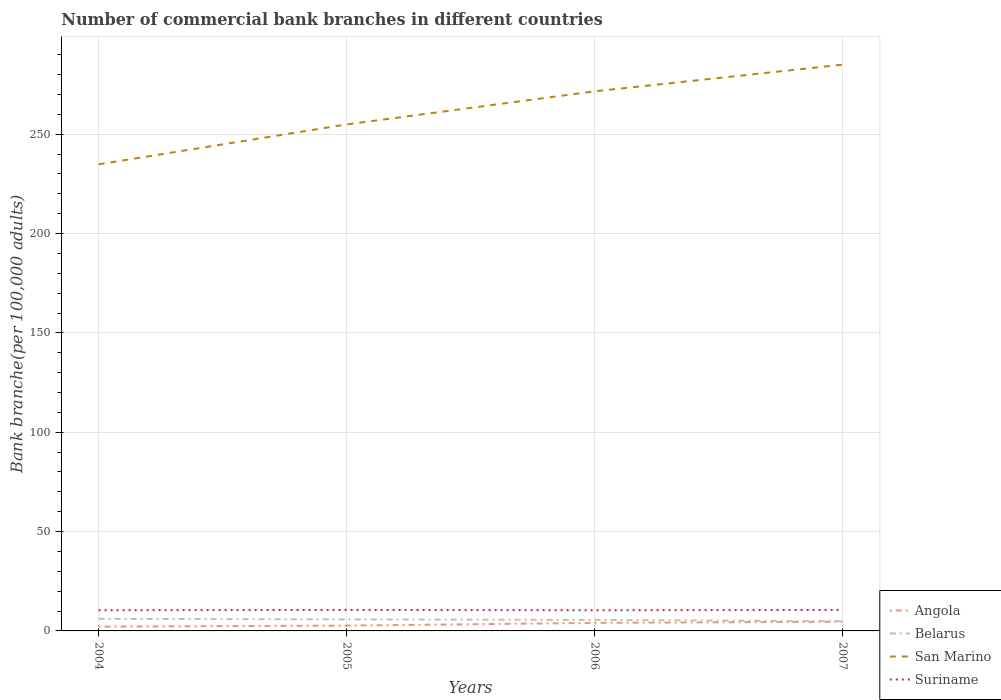How many different coloured lines are there?
Your answer should be very brief. 4. Does the line corresponding to Belarus intersect with the line corresponding to Angola?
Give a very brief answer. No. Is the number of lines equal to the number of legend labels?
Your response must be concise. Yes. Across all years, what is the maximum number of commercial bank branches in Belarus?
Your answer should be very brief. 4.87. In which year was the number of commercial bank branches in San Marino maximum?
Make the answer very short. 2004. What is the total number of commercial bank branches in Suriname in the graph?
Your answer should be compact. -0.13. What is the difference between the highest and the second highest number of commercial bank branches in Angola?
Your response must be concise. 2.49. Is the number of commercial bank branches in San Marino strictly greater than the number of commercial bank branches in Belarus over the years?
Your answer should be very brief. No. How many lines are there?
Provide a short and direct response. 4. Does the graph contain grids?
Provide a short and direct response. Yes. How many legend labels are there?
Keep it short and to the point. 4. How are the legend labels stacked?
Keep it short and to the point. Vertical. What is the title of the graph?
Offer a terse response. Number of commercial bank branches in different countries. What is the label or title of the Y-axis?
Your response must be concise. Bank branche(per 100,0 adults). What is the Bank branche(per 100,000 adults) in Angola in 2004?
Your answer should be compact. 2.16. What is the Bank branche(per 100,000 adults) in Belarus in 2004?
Provide a succinct answer. 6.09. What is the Bank branche(per 100,000 adults) in San Marino in 2004?
Ensure brevity in your answer.  234.84. What is the Bank branche(per 100,000 adults) of Suriname in 2004?
Your response must be concise. 10.43. What is the Bank branche(per 100,000 adults) of Angola in 2005?
Give a very brief answer. 2.67. What is the Bank branche(per 100,000 adults) in Belarus in 2005?
Keep it short and to the point. 5.8. What is the Bank branche(per 100,000 adults) of San Marino in 2005?
Your response must be concise. 254.92. What is the Bank branche(per 100,000 adults) of Suriname in 2005?
Keep it short and to the point. 10.56. What is the Bank branche(per 100,000 adults) in Angola in 2006?
Offer a very short reply. 4.04. What is the Bank branche(per 100,000 adults) in Belarus in 2006?
Keep it short and to the point. 5.56. What is the Bank branche(per 100,000 adults) in San Marino in 2006?
Give a very brief answer. 271.59. What is the Bank branche(per 100,000 adults) of Suriname in 2006?
Provide a short and direct response. 10.42. What is the Bank branche(per 100,000 adults) of Angola in 2007?
Keep it short and to the point. 4.64. What is the Bank branche(per 100,000 adults) in Belarus in 2007?
Keep it short and to the point. 4.87. What is the Bank branche(per 100,000 adults) in San Marino in 2007?
Offer a terse response. 285. What is the Bank branche(per 100,000 adults) of Suriname in 2007?
Your answer should be compact. 10.56. Across all years, what is the maximum Bank branche(per 100,000 adults) in Angola?
Offer a terse response. 4.64. Across all years, what is the maximum Bank branche(per 100,000 adults) in Belarus?
Ensure brevity in your answer.  6.09. Across all years, what is the maximum Bank branche(per 100,000 adults) in San Marino?
Make the answer very short. 285. Across all years, what is the maximum Bank branche(per 100,000 adults) in Suriname?
Keep it short and to the point. 10.56. Across all years, what is the minimum Bank branche(per 100,000 adults) in Angola?
Your answer should be compact. 2.16. Across all years, what is the minimum Bank branche(per 100,000 adults) in Belarus?
Your answer should be very brief. 4.87. Across all years, what is the minimum Bank branche(per 100,000 adults) of San Marino?
Offer a terse response. 234.84. Across all years, what is the minimum Bank branche(per 100,000 adults) in Suriname?
Make the answer very short. 10.42. What is the total Bank branche(per 100,000 adults) in Angola in the graph?
Offer a very short reply. 13.51. What is the total Bank branche(per 100,000 adults) in Belarus in the graph?
Your response must be concise. 22.32. What is the total Bank branche(per 100,000 adults) of San Marino in the graph?
Provide a short and direct response. 1046.35. What is the total Bank branche(per 100,000 adults) in Suriname in the graph?
Ensure brevity in your answer.  41.97. What is the difference between the Bank branche(per 100,000 adults) in Angola in 2004 and that in 2005?
Make the answer very short. -0.52. What is the difference between the Bank branche(per 100,000 adults) of Belarus in 2004 and that in 2005?
Offer a very short reply. 0.3. What is the difference between the Bank branche(per 100,000 adults) of San Marino in 2004 and that in 2005?
Offer a very short reply. -20.07. What is the difference between the Bank branche(per 100,000 adults) in Suriname in 2004 and that in 2005?
Your response must be concise. -0.14. What is the difference between the Bank branche(per 100,000 adults) in Angola in 2004 and that in 2006?
Your answer should be compact. -1.88. What is the difference between the Bank branche(per 100,000 adults) in Belarus in 2004 and that in 2006?
Offer a terse response. 0.53. What is the difference between the Bank branche(per 100,000 adults) of San Marino in 2004 and that in 2006?
Your answer should be very brief. -36.75. What is the difference between the Bank branche(per 100,000 adults) in Suriname in 2004 and that in 2006?
Your response must be concise. 0.01. What is the difference between the Bank branche(per 100,000 adults) of Angola in 2004 and that in 2007?
Provide a succinct answer. -2.49. What is the difference between the Bank branche(per 100,000 adults) in Belarus in 2004 and that in 2007?
Your answer should be compact. 1.22. What is the difference between the Bank branche(per 100,000 adults) of San Marino in 2004 and that in 2007?
Your answer should be very brief. -50.16. What is the difference between the Bank branche(per 100,000 adults) of Suriname in 2004 and that in 2007?
Provide a succinct answer. -0.13. What is the difference between the Bank branche(per 100,000 adults) in Angola in 2005 and that in 2006?
Offer a terse response. -1.37. What is the difference between the Bank branche(per 100,000 adults) of Belarus in 2005 and that in 2006?
Keep it short and to the point. 0.23. What is the difference between the Bank branche(per 100,000 adults) of San Marino in 2005 and that in 2006?
Make the answer very short. -16.68. What is the difference between the Bank branche(per 100,000 adults) of Suriname in 2005 and that in 2006?
Offer a terse response. 0.14. What is the difference between the Bank branche(per 100,000 adults) in Angola in 2005 and that in 2007?
Your response must be concise. -1.97. What is the difference between the Bank branche(per 100,000 adults) of Belarus in 2005 and that in 2007?
Give a very brief answer. 0.92. What is the difference between the Bank branche(per 100,000 adults) in San Marino in 2005 and that in 2007?
Offer a terse response. -30.09. What is the difference between the Bank branche(per 100,000 adults) of Suriname in 2005 and that in 2007?
Your response must be concise. 0. What is the difference between the Bank branche(per 100,000 adults) of Angola in 2006 and that in 2007?
Offer a terse response. -0.6. What is the difference between the Bank branche(per 100,000 adults) of Belarus in 2006 and that in 2007?
Make the answer very short. 0.69. What is the difference between the Bank branche(per 100,000 adults) of San Marino in 2006 and that in 2007?
Your answer should be compact. -13.41. What is the difference between the Bank branche(per 100,000 adults) in Suriname in 2006 and that in 2007?
Offer a very short reply. -0.14. What is the difference between the Bank branche(per 100,000 adults) of Angola in 2004 and the Bank branche(per 100,000 adults) of Belarus in 2005?
Your response must be concise. -3.64. What is the difference between the Bank branche(per 100,000 adults) in Angola in 2004 and the Bank branche(per 100,000 adults) in San Marino in 2005?
Your answer should be very brief. -252.76. What is the difference between the Bank branche(per 100,000 adults) of Angola in 2004 and the Bank branche(per 100,000 adults) of Suriname in 2005?
Offer a terse response. -8.41. What is the difference between the Bank branche(per 100,000 adults) in Belarus in 2004 and the Bank branche(per 100,000 adults) in San Marino in 2005?
Your response must be concise. -248.82. What is the difference between the Bank branche(per 100,000 adults) in Belarus in 2004 and the Bank branche(per 100,000 adults) in Suriname in 2005?
Your answer should be very brief. -4.47. What is the difference between the Bank branche(per 100,000 adults) of San Marino in 2004 and the Bank branche(per 100,000 adults) of Suriname in 2005?
Keep it short and to the point. 224.28. What is the difference between the Bank branche(per 100,000 adults) in Angola in 2004 and the Bank branche(per 100,000 adults) in Belarus in 2006?
Ensure brevity in your answer.  -3.41. What is the difference between the Bank branche(per 100,000 adults) of Angola in 2004 and the Bank branche(per 100,000 adults) of San Marino in 2006?
Your response must be concise. -269.44. What is the difference between the Bank branche(per 100,000 adults) in Angola in 2004 and the Bank branche(per 100,000 adults) in Suriname in 2006?
Keep it short and to the point. -8.26. What is the difference between the Bank branche(per 100,000 adults) of Belarus in 2004 and the Bank branche(per 100,000 adults) of San Marino in 2006?
Ensure brevity in your answer.  -265.5. What is the difference between the Bank branche(per 100,000 adults) in Belarus in 2004 and the Bank branche(per 100,000 adults) in Suriname in 2006?
Your response must be concise. -4.32. What is the difference between the Bank branche(per 100,000 adults) in San Marino in 2004 and the Bank branche(per 100,000 adults) in Suriname in 2006?
Keep it short and to the point. 224.43. What is the difference between the Bank branche(per 100,000 adults) of Angola in 2004 and the Bank branche(per 100,000 adults) of Belarus in 2007?
Your response must be concise. -2.72. What is the difference between the Bank branche(per 100,000 adults) in Angola in 2004 and the Bank branche(per 100,000 adults) in San Marino in 2007?
Offer a terse response. -282.85. What is the difference between the Bank branche(per 100,000 adults) in Angola in 2004 and the Bank branche(per 100,000 adults) in Suriname in 2007?
Provide a succinct answer. -8.4. What is the difference between the Bank branche(per 100,000 adults) of Belarus in 2004 and the Bank branche(per 100,000 adults) of San Marino in 2007?
Provide a succinct answer. -278.91. What is the difference between the Bank branche(per 100,000 adults) in Belarus in 2004 and the Bank branche(per 100,000 adults) in Suriname in 2007?
Your response must be concise. -4.47. What is the difference between the Bank branche(per 100,000 adults) in San Marino in 2004 and the Bank branche(per 100,000 adults) in Suriname in 2007?
Your answer should be very brief. 224.28. What is the difference between the Bank branche(per 100,000 adults) in Angola in 2005 and the Bank branche(per 100,000 adults) in Belarus in 2006?
Your answer should be compact. -2.89. What is the difference between the Bank branche(per 100,000 adults) in Angola in 2005 and the Bank branche(per 100,000 adults) in San Marino in 2006?
Offer a terse response. -268.92. What is the difference between the Bank branche(per 100,000 adults) of Angola in 2005 and the Bank branche(per 100,000 adults) of Suriname in 2006?
Provide a succinct answer. -7.74. What is the difference between the Bank branche(per 100,000 adults) in Belarus in 2005 and the Bank branche(per 100,000 adults) in San Marino in 2006?
Your answer should be very brief. -265.8. What is the difference between the Bank branche(per 100,000 adults) in Belarus in 2005 and the Bank branche(per 100,000 adults) in Suriname in 2006?
Make the answer very short. -4.62. What is the difference between the Bank branche(per 100,000 adults) in San Marino in 2005 and the Bank branche(per 100,000 adults) in Suriname in 2006?
Keep it short and to the point. 244.5. What is the difference between the Bank branche(per 100,000 adults) of Angola in 2005 and the Bank branche(per 100,000 adults) of Belarus in 2007?
Provide a succinct answer. -2.2. What is the difference between the Bank branche(per 100,000 adults) of Angola in 2005 and the Bank branche(per 100,000 adults) of San Marino in 2007?
Your answer should be compact. -282.33. What is the difference between the Bank branche(per 100,000 adults) in Angola in 2005 and the Bank branche(per 100,000 adults) in Suriname in 2007?
Your answer should be very brief. -7.89. What is the difference between the Bank branche(per 100,000 adults) in Belarus in 2005 and the Bank branche(per 100,000 adults) in San Marino in 2007?
Provide a succinct answer. -279.21. What is the difference between the Bank branche(per 100,000 adults) of Belarus in 2005 and the Bank branche(per 100,000 adults) of Suriname in 2007?
Make the answer very short. -4.76. What is the difference between the Bank branche(per 100,000 adults) in San Marino in 2005 and the Bank branche(per 100,000 adults) in Suriname in 2007?
Your answer should be very brief. 244.36. What is the difference between the Bank branche(per 100,000 adults) in Angola in 2006 and the Bank branche(per 100,000 adults) in Belarus in 2007?
Offer a terse response. -0.83. What is the difference between the Bank branche(per 100,000 adults) in Angola in 2006 and the Bank branche(per 100,000 adults) in San Marino in 2007?
Offer a terse response. -280.96. What is the difference between the Bank branche(per 100,000 adults) in Angola in 2006 and the Bank branche(per 100,000 adults) in Suriname in 2007?
Give a very brief answer. -6.52. What is the difference between the Bank branche(per 100,000 adults) of Belarus in 2006 and the Bank branche(per 100,000 adults) of San Marino in 2007?
Give a very brief answer. -279.44. What is the difference between the Bank branche(per 100,000 adults) in Belarus in 2006 and the Bank branche(per 100,000 adults) in Suriname in 2007?
Provide a succinct answer. -5. What is the difference between the Bank branche(per 100,000 adults) of San Marino in 2006 and the Bank branche(per 100,000 adults) of Suriname in 2007?
Your answer should be very brief. 261.03. What is the average Bank branche(per 100,000 adults) of Angola per year?
Ensure brevity in your answer.  3.38. What is the average Bank branche(per 100,000 adults) of Belarus per year?
Provide a succinct answer. 5.58. What is the average Bank branche(per 100,000 adults) of San Marino per year?
Your answer should be compact. 261.59. What is the average Bank branche(per 100,000 adults) of Suriname per year?
Ensure brevity in your answer.  10.49. In the year 2004, what is the difference between the Bank branche(per 100,000 adults) of Angola and Bank branche(per 100,000 adults) of Belarus?
Keep it short and to the point. -3.94. In the year 2004, what is the difference between the Bank branche(per 100,000 adults) of Angola and Bank branche(per 100,000 adults) of San Marino?
Your answer should be very brief. -232.69. In the year 2004, what is the difference between the Bank branche(per 100,000 adults) of Angola and Bank branche(per 100,000 adults) of Suriname?
Your answer should be compact. -8.27. In the year 2004, what is the difference between the Bank branche(per 100,000 adults) in Belarus and Bank branche(per 100,000 adults) in San Marino?
Provide a succinct answer. -228.75. In the year 2004, what is the difference between the Bank branche(per 100,000 adults) of Belarus and Bank branche(per 100,000 adults) of Suriname?
Make the answer very short. -4.33. In the year 2004, what is the difference between the Bank branche(per 100,000 adults) in San Marino and Bank branche(per 100,000 adults) in Suriname?
Ensure brevity in your answer.  224.42. In the year 2005, what is the difference between the Bank branche(per 100,000 adults) in Angola and Bank branche(per 100,000 adults) in Belarus?
Ensure brevity in your answer.  -3.12. In the year 2005, what is the difference between the Bank branche(per 100,000 adults) of Angola and Bank branche(per 100,000 adults) of San Marino?
Your answer should be compact. -252.24. In the year 2005, what is the difference between the Bank branche(per 100,000 adults) in Angola and Bank branche(per 100,000 adults) in Suriname?
Your response must be concise. -7.89. In the year 2005, what is the difference between the Bank branche(per 100,000 adults) in Belarus and Bank branche(per 100,000 adults) in San Marino?
Provide a short and direct response. -249.12. In the year 2005, what is the difference between the Bank branche(per 100,000 adults) in Belarus and Bank branche(per 100,000 adults) in Suriname?
Ensure brevity in your answer.  -4.77. In the year 2005, what is the difference between the Bank branche(per 100,000 adults) in San Marino and Bank branche(per 100,000 adults) in Suriname?
Your response must be concise. 244.35. In the year 2006, what is the difference between the Bank branche(per 100,000 adults) of Angola and Bank branche(per 100,000 adults) of Belarus?
Provide a succinct answer. -1.52. In the year 2006, what is the difference between the Bank branche(per 100,000 adults) in Angola and Bank branche(per 100,000 adults) in San Marino?
Ensure brevity in your answer.  -267.55. In the year 2006, what is the difference between the Bank branche(per 100,000 adults) in Angola and Bank branche(per 100,000 adults) in Suriname?
Make the answer very short. -6.38. In the year 2006, what is the difference between the Bank branche(per 100,000 adults) of Belarus and Bank branche(per 100,000 adults) of San Marino?
Give a very brief answer. -266.03. In the year 2006, what is the difference between the Bank branche(per 100,000 adults) in Belarus and Bank branche(per 100,000 adults) in Suriname?
Give a very brief answer. -4.86. In the year 2006, what is the difference between the Bank branche(per 100,000 adults) of San Marino and Bank branche(per 100,000 adults) of Suriname?
Offer a very short reply. 261.18. In the year 2007, what is the difference between the Bank branche(per 100,000 adults) of Angola and Bank branche(per 100,000 adults) of Belarus?
Offer a terse response. -0.23. In the year 2007, what is the difference between the Bank branche(per 100,000 adults) of Angola and Bank branche(per 100,000 adults) of San Marino?
Offer a very short reply. -280.36. In the year 2007, what is the difference between the Bank branche(per 100,000 adults) of Angola and Bank branche(per 100,000 adults) of Suriname?
Your answer should be very brief. -5.91. In the year 2007, what is the difference between the Bank branche(per 100,000 adults) of Belarus and Bank branche(per 100,000 adults) of San Marino?
Give a very brief answer. -280.13. In the year 2007, what is the difference between the Bank branche(per 100,000 adults) of Belarus and Bank branche(per 100,000 adults) of Suriname?
Make the answer very short. -5.69. In the year 2007, what is the difference between the Bank branche(per 100,000 adults) of San Marino and Bank branche(per 100,000 adults) of Suriname?
Offer a very short reply. 274.44. What is the ratio of the Bank branche(per 100,000 adults) in Angola in 2004 to that in 2005?
Ensure brevity in your answer.  0.81. What is the ratio of the Bank branche(per 100,000 adults) in Belarus in 2004 to that in 2005?
Offer a very short reply. 1.05. What is the ratio of the Bank branche(per 100,000 adults) in San Marino in 2004 to that in 2005?
Provide a short and direct response. 0.92. What is the ratio of the Bank branche(per 100,000 adults) of Suriname in 2004 to that in 2005?
Make the answer very short. 0.99. What is the ratio of the Bank branche(per 100,000 adults) in Angola in 2004 to that in 2006?
Your answer should be very brief. 0.53. What is the ratio of the Bank branche(per 100,000 adults) of Belarus in 2004 to that in 2006?
Offer a terse response. 1.1. What is the ratio of the Bank branche(per 100,000 adults) of San Marino in 2004 to that in 2006?
Keep it short and to the point. 0.86. What is the ratio of the Bank branche(per 100,000 adults) of Suriname in 2004 to that in 2006?
Provide a short and direct response. 1. What is the ratio of the Bank branche(per 100,000 adults) of Angola in 2004 to that in 2007?
Provide a short and direct response. 0.46. What is the ratio of the Bank branche(per 100,000 adults) of Belarus in 2004 to that in 2007?
Keep it short and to the point. 1.25. What is the ratio of the Bank branche(per 100,000 adults) in San Marino in 2004 to that in 2007?
Make the answer very short. 0.82. What is the ratio of the Bank branche(per 100,000 adults) of Suriname in 2004 to that in 2007?
Provide a succinct answer. 0.99. What is the ratio of the Bank branche(per 100,000 adults) in Angola in 2005 to that in 2006?
Your answer should be very brief. 0.66. What is the ratio of the Bank branche(per 100,000 adults) in Belarus in 2005 to that in 2006?
Your answer should be compact. 1.04. What is the ratio of the Bank branche(per 100,000 adults) of San Marino in 2005 to that in 2006?
Your response must be concise. 0.94. What is the ratio of the Bank branche(per 100,000 adults) of Suriname in 2005 to that in 2006?
Offer a terse response. 1.01. What is the ratio of the Bank branche(per 100,000 adults) of Angola in 2005 to that in 2007?
Offer a very short reply. 0.58. What is the ratio of the Bank branche(per 100,000 adults) in Belarus in 2005 to that in 2007?
Provide a succinct answer. 1.19. What is the ratio of the Bank branche(per 100,000 adults) of San Marino in 2005 to that in 2007?
Give a very brief answer. 0.89. What is the ratio of the Bank branche(per 100,000 adults) of Suriname in 2005 to that in 2007?
Your response must be concise. 1. What is the ratio of the Bank branche(per 100,000 adults) in Angola in 2006 to that in 2007?
Offer a very short reply. 0.87. What is the ratio of the Bank branche(per 100,000 adults) of Belarus in 2006 to that in 2007?
Your answer should be very brief. 1.14. What is the ratio of the Bank branche(per 100,000 adults) in San Marino in 2006 to that in 2007?
Make the answer very short. 0.95. What is the ratio of the Bank branche(per 100,000 adults) in Suriname in 2006 to that in 2007?
Your answer should be compact. 0.99. What is the difference between the highest and the second highest Bank branche(per 100,000 adults) of Angola?
Ensure brevity in your answer.  0.6. What is the difference between the highest and the second highest Bank branche(per 100,000 adults) in Belarus?
Ensure brevity in your answer.  0.3. What is the difference between the highest and the second highest Bank branche(per 100,000 adults) of San Marino?
Make the answer very short. 13.41. What is the difference between the highest and the second highest Bank branche(per 100,000 adults) in Suriname?
Provide a short and direct response. 0. What is the difference between the highest and the lowest Bank branche(per 100,000 adults) in Angola?
Provide a succinct answer. 2.49. What is the difference between the highest and the lowest Bank branche(per 100,000 adults) of Belarus?
Keep it short and to the point. 1.22. What is the difference between the highest and the lowest Bank branche(per 100,000 adults) in San Marino?
Your answer should be compact. 50.16. What is the difference between the highest and the lowest Bank branche(per 100,000 adults) of Suriname?
Provide a succinct answer. 0.14. 